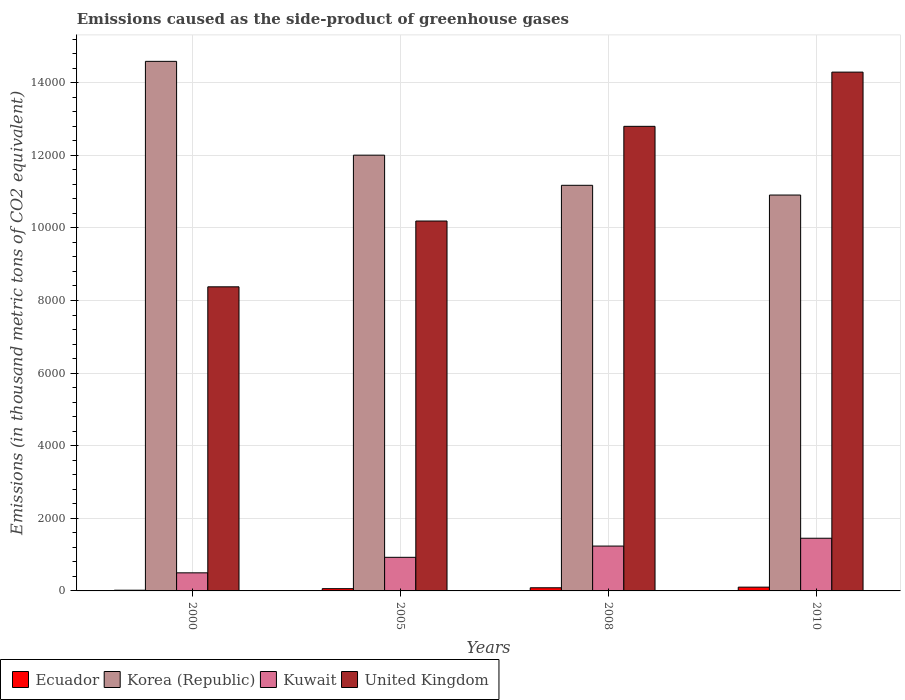How many different coloured bars are there?
Ensure brevity in your answer.  4. How many groups of bars are there?
Ensure brevity in your answer.  4. Are the number of bars per tick equal to the number of legend labels?
Your answer should be compact. Yes. What is the label of the 3rd group of bars from the left?
Your answer should be very brief. 2008. In how many cases, is the number of bars for a given year not equal to the number of legend labels?
Ensure brevity in your answer.  0. What is the emissions caused as the side-product of greenhouse gases in Kuwait in 2005?
Ensure brevity in your answer.  925.6. Across all years, what is the maximum emissions caused as the side-product of greenhouse gases in United Kingdom?
Give a very brief answer. 1.43e+04. Across all years, what is the minimum emissions caused as the side-product of greenhouse gases in Korea (Republic)?
Your answer should be compact. 1.09e+04. In which year was the emissions caused as the side-product of greenhouse gases in Korea (Republic) minimum?
Your response must be concise. 2010. What is the total emissions caused as the side-product of greenhouse gases in Korea (Republic) in the graph?
Keep it short and to the point. 4.87e+04. What is the difference between the emissions caused as the side-product of greenhouse gases in Korea (Republic) in 2005 and that in 2010?
Your answer should be very brief. 1098.3. What is the difference between the emissions caused as the side-product of greenhouse gases in United Kingdom in 2000 and the emissions caused as the side-product of greenhouse gases in Ecuador in 2008?
Your response must be concise. 8290. What is the average emissions caused as the side-product of greenhouse gases in Kuwait per year?
Ensure brevity in your answer.  1027.55. In the year 2008, what is the difference between the emissions caused as the side-product of greenhouse gases in Ecuador and emissions caused as the side-product of greenhouse gases in United Kingdom?
Make the answer very short. -1.27e+04. In how many years, is the emissions caused as the side-product of greenhouse gases in Ecuador greater than 14800 thousand metric tons?
Your answer should be compact. 0. What is the ratio of the emissions caused as the side-product of greenhouse gases in United Kingdom in 2000 to that in 2008?
Offer a terse response. 0.65. Is the emissions caused as the side-product of greenhouse gases in United Kingdom in 2005 less than that in 2008?
Give a very brief answer. Yes. What is the difference between the highest and the second highest emissions caused as the side-product of greenhouse gases in Ecuador?
Make the answer very short. 17.3. What is the difference between the highest and the lowest emissions caused as the side-product of greenhouse gases in Korea (Republic)?
Your answer should be compact. 3682.3. In how many years, is the emissions caused as the side-product of greenhouse gases in Kuwait greater than the average emissions caused as the side-product of greenhouse gases in Kuwait taken over all years?
Keep it short and to the point. 2. What does the 1st bar from the left in 2008 represents?
Provide a succinct answer. Ecuador. What does the 3rd bar from the right in 2008 represents?
Your answer should be very brief. Korea (Republic). Is it the case that in every year, the sum of the emissions caused as the side-product of greenhouse gases in Korea (Republic) and emissions caused as the side-product of greenhouse gases in Kuwait is greater than the emissions caused as the side-product of greenhouse gases in United Kingdom?
Offer a very short reply. No. Are all the bars in the graph horizontal?
Your answer should be compact. No. How many years are there in the graph?
Your answer should be compact. 4. What is the difference between two consecutive major ticks on the Y-axis?
Offer a very short reply. 2000. Are the values on the major ticks of Y-axis written in scientific E-notation?
Keep it short and to the point. No. Does the graph contain grids?
Offer a very short reply. Yes. How are the legend labels stacked?
Keep it short and to the point. Horizontal. What is the title of the graph?
Ensure brevity in your answer.  Emissions caused as the side-product of greenhouse gases. What is the label or title of the Y-axis?
Provide a succinct answer. Emissions (in thousand metric tons of CO2 equivalent). What is the Emissions (in thousand metric tons of CO2 equivalent) in Korea (Republic) in 2000?
Give a very brief answer. 1.46e+04. What is the Emissions (in thousand metric tons of CO2 equivalent) of Kuwait in 2000?
Offer a terse response. 498.2. What is the Emissions (in thousand metric tons of CO2 equivalent) of United Kingdom in 2000?
Ensure brevity in your answer.  8376.7. What is the Emissions (in thousand metric tons of CO2 equivalent) of Ecuador in 2005?
Offer a very short reply. 62.2. What is the Emissions (in thousand metric tons of CO2 equivalent) in Korea (Republic) in 2005?
Ensure brevity in your answer.  1.20e+04. What is the Emissions (in thousand metric tons of CO2 equivalent) in Kuwait in 2005?
Provide a succinct answer. 925.6. What is the Emissions (in thousand metric tons of CO2 equivalent) in United Kingdom in 2005?
Offer a very short reply. 1.02e+04. What is the Emissions (in thousand metric tons of CO2 equivalent) in Ecuador in 2008?
Keep it short and to the point. 86.7. What is the Emissions (in thousand metric tons of CO2 equivalent) in Korea (Republic) in 2008?
Your answer should be compact. 1.12e+04. What is the Emissions (in thousand metric tons of CO2 equivalent) in Kuwait in 2008?
Offer a very short reply. 1235.4. What is the Emissions (in thousand metric tons of CO2 equivalent) of United Kingdom in 2008?
Make the answer very short. 1.28e+04. What is the Emissions (in thousand metric tons of CO2 equivalent) in Ecuador in 2010?
Your answer should be very brief. 104. What is the Emissions (in thousand metric tons of CO2 equivalent) of Korea (Republic) in 2010?
Your response must be concise. 1.09e+04. What is the Emissions (in thousand metric tons of CO2 equivalent) in Kuwait in 2010?
Provide a succinct answer. 1451. What is the Emissions (in thousand metric tons of CO2 equivalent) in United Kingdom in 2010?
Provide a short and direct response. 1.43e+04. Across all years, what is the maximum Emissions (in thousand metric tons of CO2 equivalent) of Ecuador?
Your response must be concise. 104. Across all years, what is the maximum Emissions (in thousand metric tons of CO2 equivalent) of Korea (Republic)?
Offer a very short reply. 1.46e+04. Across all years, what is the maximum Emissions (in thousand metric tons of CO2 equivalent) in Kuwait?
Your answer should be very brief. 1451. Across all years, what is the maximum Emissions (in thousand metric tons of CO2 equivalent) of United Kingdom?
Make the answer very short. 1.43e+04. Across all years, what is the minimum Emissions (in thousand metric tons of CO2 equivalent) in Korea (Republic)?
Make the answer very short. 1.09e+04. Across all years, what is the minimum Emissions (in thousand metric tons of CO2 equivalent) in Kuwait?
Your answer should be compact. 498.2. Across all years, what is the minimum Emissions (in thousand metric tons of CO2 equivalent) in United Kingdom?
Offer a very short reply. 8376.7. What is the total Emissions (in thousand metric tons of CO2 equivalent) in Ecuador in the graph?
Offer a very short reply. 272.6. What is the total Emissions (in thousand metric tons of CO2 equivalent) in Korea (Republic) in the graph?
Your answer should be very brief. 4.87e+04. What is the total Emissions (in thousand metric tons of CO2 equivalent) in Kuwait in the graph?
Ensure brevity in your answer.  4110.2. What is the total Emissions (in thousand metric tons of CO2 equivalent) of United Kingdom in the graph?
Your answer should be very brief. 4.57e+04. What is the difference between the Emissions (in thousand metric tons of CO2 equivalent) of Ecuador in 2000 and that in 2005?
Offer a very short reply. -42.5. What is the difference between the Emissions (in thousand metric tons of CO2 equivalent) in Korea (Republic) in 2000 and that in 2005?
Keep it short and to the point. 2584. What is the difference between the Emissions (in thousand metric tons of CO2 equivalent) of Kuwait in 2000 and that in 2005?
Offer a terse response. -427.4. What is the difference between the Emissions (in thousand metric tons of CO2 equivalent) in United Kingdom in 2000 and that in 2005?
Your answer should be very brief. -1812.3. What is the difference between the Emissions (in thousand metric tons of CO2 equivalent) of Ecuador in 2000 and that in 2008?
Your answer should be very brief. -67. What is the difference between the Emissions (in thousand metric tons of CO2 equivalent) of Korea (Republic) in 2000 and that in 2008?
Make the answer very short. 3414.4. What is the difference between the Emissions (in thousand metric tons of CO2 equivalent) in Kuwait in 2000 and that in 2008?
Give a very brief answer. -737.2. What is the difference between the Emissions (in thousand metric tons of CO2 equivalent) in United Kingdom in 2000 and that in 2008?
Give a very brief answer. -4420.6. What is the difference between the Emissions (in thousand metric tons of CO2 equivalent) of Ecuador in 2000 and that in 2010?
Provide a succinct answer. -84.3. What is the difference between the Emissions (in thousand metric tons of CO2 equivalent) in Korea (Republic) in 2000 and that in 2010?
Your answer should be very brief. 3682.3. What is the difference between the Emissions (in thousand metric tons of CO2 equivalent) of Kuwait in 2000 and that in 2010?
Offer a terse response. -952.8. What is the difference between the Emissions (in thousand metric tons of CO2 equivalent) of United Kingdom in 2000 and that in 2010?
Give a very brief answer. -5914.3. What is the difference between the Emissions (in thousand metric tons of CO2 equivalent) in Ecuador in 2005 and that in 2008?
Offer a very short reply. -24.5. What is the difference between the Emissions (in thousand metric tons of CO2 equivalent) in Korea (Republic) in 2005 and that in 2008?
Offer a very short reply. 830.4. What is the difference between the Emissions (in thousand metric tons of CO2 equivalent) of Kuwait in 2005 and that in 2008?
Make the answer very short. -309.8. What is the difference between the Emissions (in thousand metric tons of CO2 equivalent) in United Kingdom in 2005 and that in 2008?
Ensure brevity in your answer.  -2608.3. What is the difference between the Emissions (in thousand metric tons of CO2 equivalent) of Ecuador in 2005 and that in 2010?
Provide a succinct answer. -41.8. What is the difference between the Emissions (in thousand metric tons of CO2 equivalent) in Korea (Republic) in 2005 and that in 2010?
Provide a succinct answer. 1098.3. What is the difference between the Emissions (in thousand metric tons of CO2 equivalent) in Kuwait in 2005 and that in 2010?
Ensure brevity in your answer.  -525.4. What is the difference between the Emissions (in thousand metric tons of CO2 equivalent) of United Kingdom in 2005 and that in 2010?
Offer a very short reply. -4102. What is the difference between the Emissions (in thousand metric tons of CO2 equivalent) of Ecuador in 2008 and that in 2010?
Your answer should be compact. -17.3. What is the difference between the Emissions (in thousand metric tons of CO2 equivalent) of Korea (Republic) in 2008 and that in 2010?
Offer a terse response. 267.9. What is the difference between the Emissions (in thousand metric tons of CO2 equivalent) in Kuwait in 2008 and that in 2010?
Give a very brief answer. -215.6. What is the difference between the Emissions (in thousand metric tons of CO2 equivalent) in United Kingdom in 2008 and that in 2010?
Your answer should be compact. -1493.7. What is the difference between the Emissions (in thousand metric tons of CO2 equivalent) in Ecuador in 2000 and the Emissions (in thousand metric tons of CO2 equivalent) in Korea (Republic) in 2005?
Keep it short and to the point. -1.20e+04. What is the difference between the Emissions (in thousand metric tons of CO2 equivalent) in Ecuador in 2000 and the Emissions (in thousand metric tons of CO2 equivalent) in Kuwait in 2005?
Offer a terse response. -905.9. What is the difference between the Emissions (in thousand metric tons of CO2 equivalent) in Ecuador in 2000 and the Emissions (in thousand metric tons of CO2 equivalent) in United Kingdom in 2005?
Provide a short and direct response. -1.02e+04. What is the difference between the Emissions (in thousand metric tons of CO2 equivalent) in Korea (Republic) in 2000 and the Emissions (in thousand metric tons of CO2 equivalent) in Kuwait in 2005?
Give a very brief answer. 1.37e+04. What is the difference between the Emissions (in thousand metric tons of CO2 equivalent) of Korea (Republic) in 2000 and the Emissions (in thousand metric tons of CO2 equivalent) of United Kingdom in 2005?
Make the answer very short. 4398.3. What is the difference between the Emissions (in thousand metric tons of CO2 equivalent) in Kuwait in 2000 and the Emissions (in thousand metric tons of CO2 equivalent) in United Kingdom in 2005?
Provide a succinct answer. -9690.8. What is the difference between the Emissions (in thousand metric tons of CO2 equivalent) of Ecuador in 2000 and the Emissions (in thousand metric tons of CO2 equivalent) of Korea (Republic) in 2008?
Give a very brief answer. -1.12e+04. What is the difference between the Emissions (in thousand metric tons of CO2 equivalent) of Ecuador in 2000 and the Emissions (in thousand metric tons of CO2 equivalent) of Kuwait in 2008?
Offer a terse response. -1215.7. What is the difference between the Emissions (in thousand metric tons of CO2 equivalent) of Ecuador in 2000 and the Emissions (in thousand metric tons of CO2 equivalent) of United Kingdom in 2008?
Offer a very short reply. -1.28e+04. What is the difference between the Emissions (in thousand metric tons of CO2 equivalent) of Korea (Republic) in 2000 and the Emissions (in thousand metric tons of CO2 equivalent) of Kuwait in 2008?
Provide a short and direct response. 1.34e+04. What is the difference between the Emissions (in thousand metric tons of CO2 equivalent) of Korea (Republic) in 2000 and the Emissions (in thousand metric tons of CO2 equivalent) of United Kingdom in 2008?
Provide a succinct answer. 1790. What is the difference between the Emissions (in thousand metric tons of CO2 equivalent) of Kuwait in 2000 and the Emissions (in thousand metric tons of CO2 equivalent) of United Kingdom in 2008?
Keep it short and to the point. -1.23e+04. What is the difference between the Emissions (in thousand metric tons of CO2 equivalent) of Ecuador in 2000 and the Emissions (in thousand metric tons of CO2 equivalent) of Korea (Republic) in 2010?
Provide a short and direct response. -1.09e+04. What is the difference between the Emissions (in thousand metric tons of CO2 equivalent) in Ecuador in 2000 and the Emissions (in thousand metric tons of CO2 equivalent) in Kuwait in 2010?
Keep it short and to the point. -1431.3. What is the difference between the Emissions (in thousand metric tons of CO2 equivalent) of Ecuador in 2000 and the Emissions (in thousand metric tons of CO2 equivalent) of United Kingdom in 2010?
Make the answer very short. -1.43e+04. What is the difference between the Emissions (in thousand metric tons of CO2 equivalent) in Korea (Republic) in 2000 and the Emissions (in thousand metric tons of CO2 equivalent) in Kuwait in 2010?
Offer a terse response. 1.31e+04. What is the difference between the Emissions (in thousand metric tons of CO2 equivalent) of Korea (Republic) in 2000 and the Emissions (in thousand metric tons of CO2 equivalent) of United Kingdom in 2010?
Ensure brevity in your answer.  296.3. What is the difference between the Emissions (in thousand metric tons of CO2 equivalent) in Kuwait in 2000 and the Emissions (in thousand metric tons of CO2 equivalent) in United Kingdom in 2010?
Make the answer very short. -1.38e+04. What is the difference between the Emissions (in thousand metric tons of CO2 equivalent) of Ecuador in 2005 and the Emissions (in thousand metric tons of CO2 equivalent) of Korea (Republic) in 2008?
Ensure brevity in your answer.  -1.11e+04. What is the difference between the Emissions (in thousand metric tons of CO2 equivalent) in Ecuador in 2005 and the Emissions (in thousand metric tons of CO2 equivalent) in Kuwait in 2008?
Give a very brief answer. -1173.2. What is the difference between the Emissions (in thousand metric tons of CO2 equivalent) of Ecuador in 2005 and the Emissions (in thousand metric tons of CO2 equivalent) of United Kingdom in 2008?
Provide a short and direct response. -1.27e+04. What is the difference between the Emissions (in thousand metric tons of CO2 equivalent) in Korea (Republic) in 2005 and the Emissions (in thousand metric tons of CO2 equivalent) in Kuwait in 2008?
Offer a terse response. 1.08e+04. What is the difference between the Emissions (in thousand metric tons of CO2 equivalent) in Korea (Republic) in 2005 and the Emissions (in thousand metric tons of CO2 equivalent) in United Kingdom in 2008?
Keep it short and to the point. -794. What is the difference between the Emissions (in thousand metric tons of CO2 equivalent) of Kuwait in 2005 and the Emissions (in thousand metric tons of CO2 equivalent) of United Kingdom in 2008?
Offer a very short reply. -1.19e+04. What is the difference between the Emissions (in thousand metric tons of CO2 equivalent) in Ecuador in 2005 and the Emissions (in thousand metric tons of CO2 equivalent) in Korea (Republic) in 2010?
Offer a very short reply. -1.08e+04. What is the difference between the Emissions (in thousand metric tons of CO2 equivalent) in Ecuador in 2005 and the Emissions (in thousand metric tons of CO2 equivalent) in Kuwait in 2010?
Give a very brief answer. -1388.8. What is the difference between the Emissions (in thousand metric tons of CO2 equivalent) in Ecuador in 2005 and the Emissions (in thousand metric tons of CO2 equivalent) in United Kingdom in 2010?
Give a very brief answer. -1.42e+04. What is the difference between the Emissions (in thousand metric tons of CO2 equivalent) in Korea (Republic) in 2005 and the Emissions (in thousand metric tons of CO2 equivalent) in Kuwait in 2010?
Provide a succinct answer. 1.06e+04. What is the difference between the Emissions (in thousand metric tons of CO2 equivalent) of Korea (Republic) in 2005 and the Emissions (in thousand metric tons of CO2 equivalent) of United Kingdom in 2010?
Provide a short and direct response. -2287.7. What is the difference between the Emissions (in thousand metric tons of CO2 equivalent) of Kuwait in 2005 and the Emissions (in thousand metric tons of CO2 equivalent) of United Kingdom in 2010?
Your response must be concise. -1.34e+04. What is the difference between the Emissions (in thousand metric tons of CO2 equivalent) of Ecuador in 2008 and the Emissions (in thousand metric tons of CO2 equivalent) of Korea (Republic) in 2010?
Keep it short and to the point. -1.08e+04. What is the difference between the Emissions (in thousand metric tons of CO2 equivalent) in Ecuador in 2008 and the Emissions (in thousand metric tons of CO2 equivalent) in Kuwait in 2010?
Your answer should be very brief. -1364.3. What is the difference between the Emissions (in thousand metric tons of CO2 equivalent) in Ecuador in 2008 and the Emissions (in thousand metric tons of CO2 equivalent) in United Kingdom in 2010?
Your answer should be very brief. -1.42e+04. What is the difference between the Emissions (in thousand metric tons of CO2 equivalent) of Korea (Republic) in 2008 and the Emissions (in thousand metric tons of CO2 equivalent) of Kuwait in 2010?
Provide a succinct answer. 9721.9. What is the difference between the Emissions (in thousand metric tons of CO2 equivalent) in Korea (Republic) in 2008 and the Emissions (in thousand metric tons of CO2 equivalent) in United Kingdom in 2010?
Provide a succinct answer. -3118.1. What is the difference between the Emissions (in thousand metric tons of CO2 equivalent) in Kuwait in 2008 and the Emissions (in thousand metric tons of CO2 equivalent) in United Kingdom in 2010?
Your response must be concise. -1.31e+04. What is the average Emissions (in thousand metric tons of CO2 equivalent) in Ecuador per year?
Give a very brief answer. 68.15. What is the average Emissions (in thousand metric tons of CO2 equivalent) in Korea (Republic) per year?
Ensure brevity in your answer.  1.22e+04. What is the average Emissions (in thousand metric tons of CO2 equivalent) in Kuwait per year?
Make the answer very short. 1027.55. What is the average Emissions (in thousand metric tons of CO2 equivalent) of United Kingdom per year?
Make the answer very short. 1.14e+04. In the year 2000, what is the difference between the Emissions (in thousand metric tons of CO2 equivalent) in Ecuador and Emissions (in thousand metric tons of CO2 equivalent) in Korea (Republic)?
Ensure brevity in your answer.  -1.46e+04. In the year 2000, what is the difference between the Emissions (in thousand metric tons of CO2 equivalent) in Ecuador and Emissions (in thousand metric tons of CO2 equivalent) in Kuwait?
Give a very brief answer. -478.5. In the year 2000, what is the difference between the Emissions (in thousand metric tons of CO2 equivalent) of Ecuador and Emissions (in thousand metric tons of CO2 equivalent) of United Kingdom?
Make the answer very short. -8357. In the year 2000, what is the difference between the Emissions (in thousand metric tons of CO2 equivalent) in Korea (Republic) and Emissions (in thousand metric tons of CO2 equivalent) in Kuwait?
Provide a succinct answer. 1.41e+04. In the year 2000, what is the difference between the Emissions (in thousand metric tons of CO2 equivalent) in Korea (Republic) and Emissions (in thousand metric tons of CO2 equivalent) in United Kingdom?
Your answer should be compact. 6210.6. In the year 2000, what is the difference between the Emissions (in thousand metric tons of CO2 equivalent) of Kuwait and Emissions (in thousand metric tons of CO2 equivalent) of United Kingdom?
Provide a succinct answer. -7878.5. In the year 2005, what is the difference between the Emissions (in thousand metric tons of CO2 equivalent) in Ecuador and Emissions (in thousand metric tons of CO2 equivalent) in Korea (Republic)?
Give a very brief answer. -1.19e+04. In the year 2005, what is the difference between the Emissions (in thousand metric tons of CO2 equivalent) in Ecuador and Emissions (in thousand metric tons of CO2 equivalent) in Kuwait?
Make the answer very short. -863.4. In the year 2005, what is the difference between the Emissions (in thousand metric tons of CO2 equivalent) of Ecuador and Emissions (in thousand metric tons of CO2 equivalent) of United Kingdom?
Keep it short and to the point. -1.01e+04. In the year 2005, what is the difference between the Emissions (in thousand metric tons of CO2 equivalent) of Korea (Republic) and Emissions (in thousand metric tons of CO2 equivalent) of Kuwait?
Make the answer very short. 1.11e+04. In the year 2005, what is the difference between the Emissions (in thousand metric tons of CO2 equivalent) of Korea (Republic) and Emissions (in thousand metric tons of CO2 equivalent) of United Kingdom?
Ensure brevity in your answer.  1814.3. In the year 2005, what is the difference between the Emissions (in thousand metric tons of CO2 equivalent) in Kuwait and Emissions (in thousand metric tons of CO2 equivalent) in United Kingdom?
Ensure brevity in your answer.  -9263.4. In the year 2008, what is the difference between the Emissions (in thousand metric tons of CO2 equivalent) in Ecuador and Emissions (in thousand metric tons of CO2 equivalent) in Korea (Republic)?
Offer a very short reply. -1.11e+04. In the year 2008, what is the difference between the Emissions (in thousand metric tons of CO2 equivalent) of Ecuador and Emissions (in thousand metric tons of CO2 equivalent) of Kuwait?
Your response must be concise. -1148.7. In the year 2008, what is the difference between the Emissions (in thousand metric tons of CO2 equivalent) of Ecuador and Emissions (in thousand metric tons of CO2 equivalent) of United Kingdom?
Provide a short and direct response. -1.27e+04. In the year 2008, what is the difference between the Emissions (in thousand metric tons of CO2 equivalent) in Korea (Republic) and Emissions (in thousand metric tons of CO2 equivalent) in Kuwait?
Give a very brief answer. 9937.5. In the year 2008, what is the difference between the Emissions (in thousand metric tons of CO2 equivalent) of Korea (Republic) and Emissions (in thousand metric tons of CO2 equivalent) of United Kingdom?
Make the answer very short. -1624.4. In the year 2008, what is the difference between the Emissions (in thousand metric tons of CO2 equivalent) in Kuwait and Emissions (in thousand metric tons of CO2 equivalent) in United Kingdom?
Your answer should be very brief. -1.16e+04. In the year 2010, what is the difference between the Emissions (in thousand metric tons of CO2 equivalent) in Ecuador and Emissions (in thousand metric tons of CO2 equivalent) in Korea (Republic)?
Offer a very short reply. -1.08e+04. In the year 2010, what is the difference between the Emissions (in thousand metric tons of CO2 equivalent) of Ecuador and Emissions (in thousand metric tons of CO2 equivalent) of Kuwait?
Offer a very short reply. -1347. In the year 2010, what is the difference between the Emissions (in thousand metric tons of CO2 equivalent) of Ecuador and Emissions (in thousand metric tons of CO2 equivalent) of United Kingdom?
Your answer should be very brief. -1.42e+04. In the year 2010, what is the difference between the Emissions (in thousand metric tons of CO2 equivalent) of Korea (Republic) and Emissions (in thousand metric tons of CO2 equivalent) of Kuwait?
Your answer should be compact. 9454. In the year 2010, what is the difference between the Emissions (in thousand metric tons of CO2 equivalent) of Korea (Republic) and Emissions (in thousand metric tons of CO2 equivalent) of United Kingdom?
Keep it short and to the point. -3386. In the year 2010, what is the difference between the Emissions (in thousand metric tons of CO2 equivalent) in Kuwait and Emissions (in thousand metric tons of CO2 equivalent) in United Kingdom?
Provide a succinct answer. -1.28e+04. What is the ratio of the Emissions (in thousand metric tons of CO2 equivalent) of Ecuador in 2000 to that in 2005?
Provide a short and direct response. 0.32. What is the ratio of the Emissions (in thousand metric tons of CO2 equivalent) of Korea (Republic) in 2000 to that in 2005?
Ensure brevity in your answer.  1.22. What is the ratio of the Emissions (in thousand metric tons of CO2 equivalent) of Kuwait in 2000 to that in 2005?
Your answer should be very brief. 0.54. What is the ratio of the Emissions (in thousand metric tons of CO2 equivalent) in United Kingdom in 2000 to that in 2005?
Your response must be concise. 0.82. What is the ratio of the Emissions (in thousand metric tons of CO2 equivalent) of Ecuador in 2000 to that in 2008?
Provide a succinct answer. 0.23. What is the ratio of the Emissions (in thousand metric tons of CO2 equivalent) in Korea (Republic) in 2000 to that in 2008?
Your answer should be very brief. 1.31. What is the ratio of the Emissions (in thousand metric tons of CO2 equivalent) in Kuwait in 2000 to that in 2008?
Ensure brevity in your answer.  0.4. What is the ratio of the Emissions (in thousand metric tons of CO2 equivalent) of United Kingdom in 2000 to that in 2008?
Offer a very short reply. 0.65. What is the ratio of the Emissions (in thousand metric tons of CO2 equivalent) of Ecuador in 2000 to that in 2010?
Offer a very short reply. 0.19. What is the ratio of the Emissions (in thousand metric tons of CO2 equivalent) in Korea (Republic) in 2000 to that in 2010?
Your response must be concise. 1.34. What is the ratio of the Emissions (in thousand metric tons of CO2 equivalent) of Kuwait in 2000 to that in 2010?
Your answer should be very brief. 0.34. What is the ratio of the Emissions (in thousand metric tons of CO2 equivalent) of United Kingdom in 2000 to that in 2010?
Give a very brief answer. 0.59. What is the ratio of the Emissions (in thousand metric tons of CO2 equivalent) of Ecuador in 2005 to that in 2008?
Your answer should be very brief. 0.72. What is the ratio of the Emissions (in thousand metric tons of CO2 equivalent) in Korea (Republic) in 2005 to that in 2008?
Offer a very short reply. 1.07. What is the ratio of the Emissions (in thousand metric tons of CO2 equivalent) of Kuwait in 2005 to that in 2008?
Your response must be concise. 0.75. What is the ratio of the Emissions (in thousand metric tons of CO2 equivalent) of United Kingdom in 2005 to that in 2008?
Ensure brevity in your answer.  0.8. What is the ratio of the Emissions (in thousand metric tons of CO2 equivalent) in Ecuador in 2005 to that in 2010?
Offer a very short reply. 0.6. What is the ratio of the Emissions (in thousand metric tons of CO2 equivalent) of Korea (Republic) in 2005 to that in 2010?
Keep it short and to the point. 1.1. What is the ratio of the Emissions (in thousand metric tons of CO2 equivalent) in Kuwait in 2005 to that in 2010?
Provide a succinct answer. 0.64. What is the ratio of the Emissions (in thousand metric tons of CO2 equivalent) in United Kingdom in 2005 to that in 2010?
Give a very brief answer. 0.71. What is the ratio of the Emissions (in thousand metric tons of CO2 equivalent) of Ecuador in 2008 to that in 2010?
Keep it short and to the point. 0.83. What is the ratio of the Emissions (in thousand metric tons of CO2 equivalent) of Korea (Republic) in 2008 to that in 2010?
Make the answer very short. 1.02. What is the ratio of the Emissions (in thousand metric tons of CO2 equivalent) of Kuwait in 2008 to that in 2010?
Your answer should be very brief. 0.85. What is the ratio of the Emissions (in thousand metric tons of CO2 equivalent) in United Kingdom in 2008 to that in 2010?
Provide a succinct answer. 0.9. What is the difference between the highest and the second highest Emissions (in thousand metric tons of CO2 equivalent) of Korea (Republic)?
Give a very brief answer. 2584. What is the difference between the highest and the second highest Emissions (in thousand metric tons of CO2 equivalent) of Kuwait?
Your answer should be very brief. 215.6. What is the difference between the highest and the second highest Emissions (in thousand metric tons of CO2 equivalent) of United Kingdom?
Offer a terse response. 1493.7. What is the difference between the highest and the lowest Emissions (in thousand metric tons of CO2 equivalent) of Ecuador?
Ensure brevity in your answer.  84.3. What is the difference between the highest and the lowest Emissions (in thousand metric tons of CO2 equivalent) in Korea (Republic)?
Your answer should be compact. 3682.3. What is the difference between the highest and the lowest Emissions (in thousand metric tons of CO2 equivalent) in Kuwait?
Offer a very short reply. 952.8. What is the difference between the highest and the lowest Emissions (in thousand metric tons of CO2 equivalent) of United Kingdom?
Provide a succinct answer. 5914.3. 